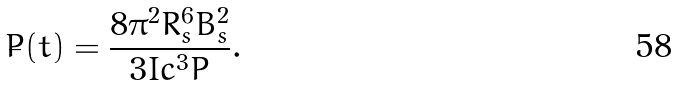<formula> <loc_0><loc_0><loc_500><loc_500>\dot { P } ( t ) = \frac { 8 \pi ^ { 2 } R _ { s } ^ { 6 } B _ { s } ^ { 2 } } { 3 I c ^ { 3 } P } .</formula> 